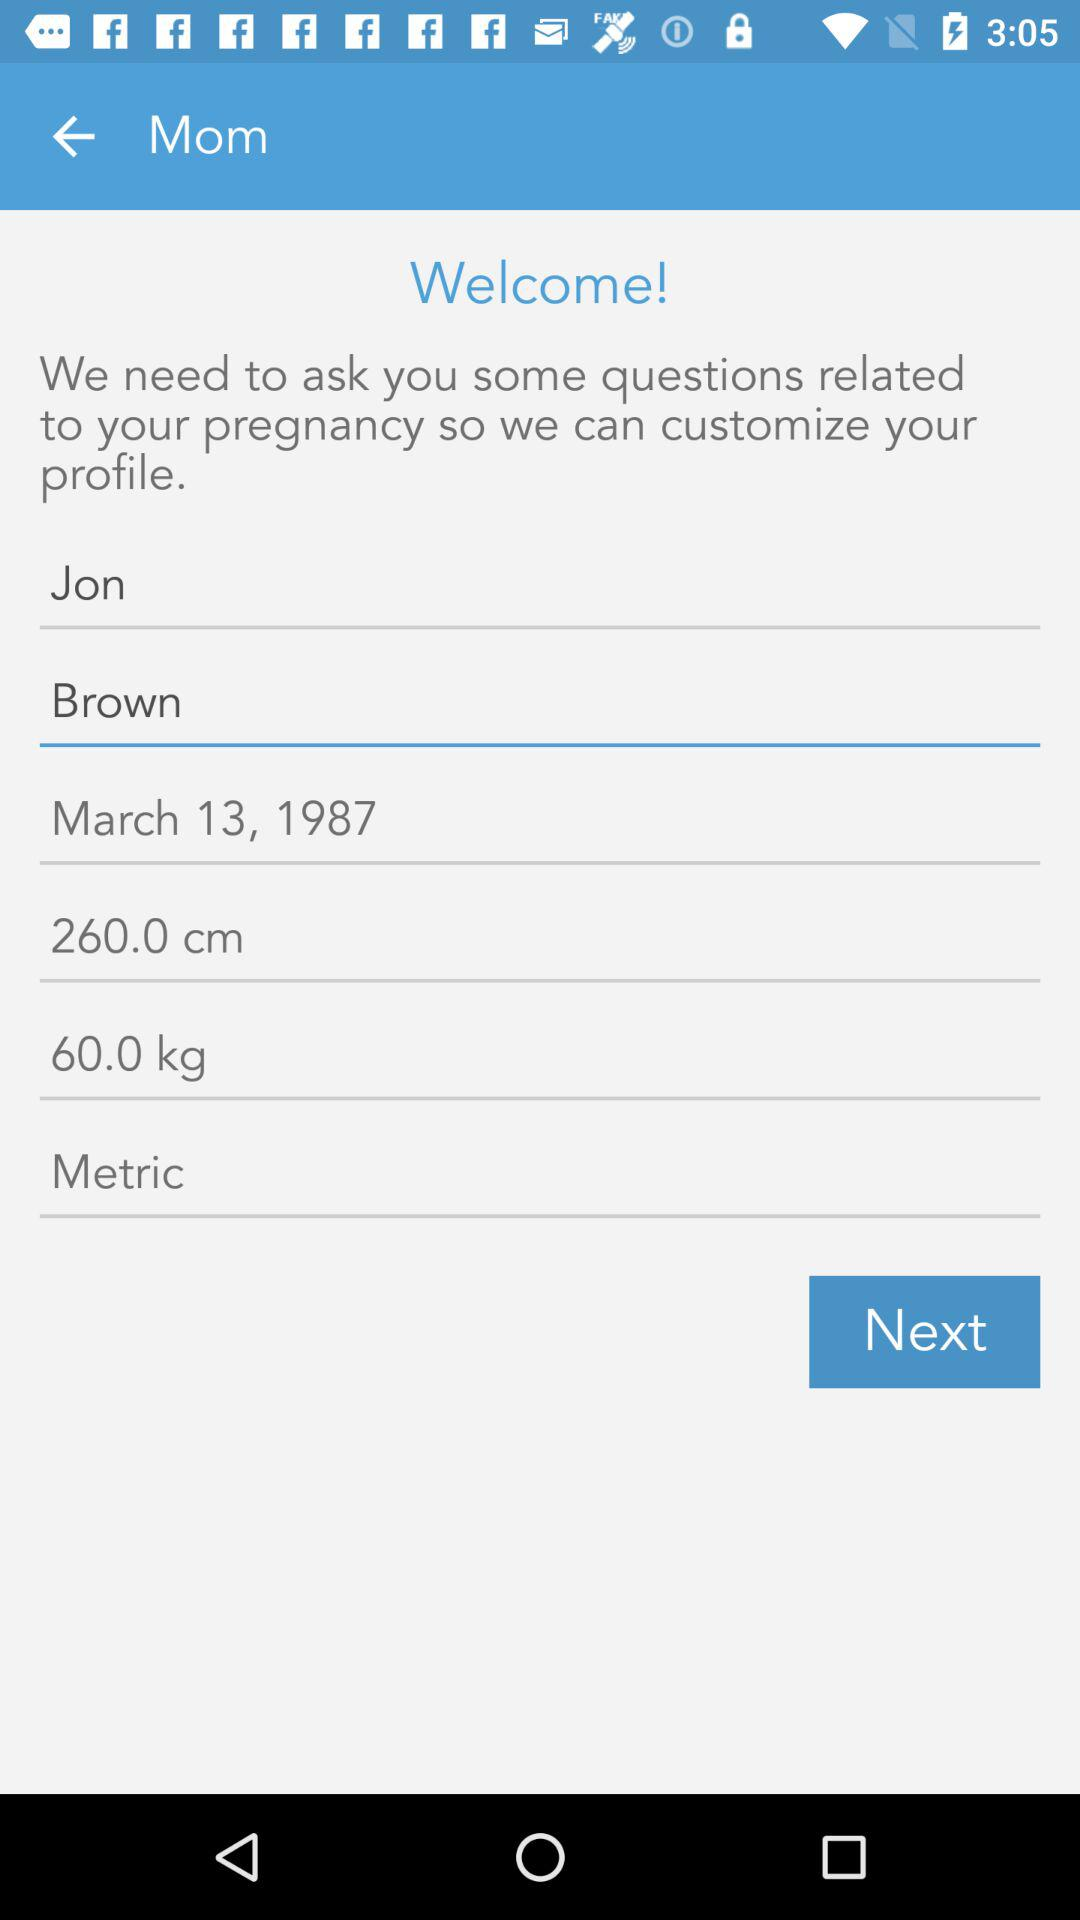What is the date? The date is March 13, 1987. 